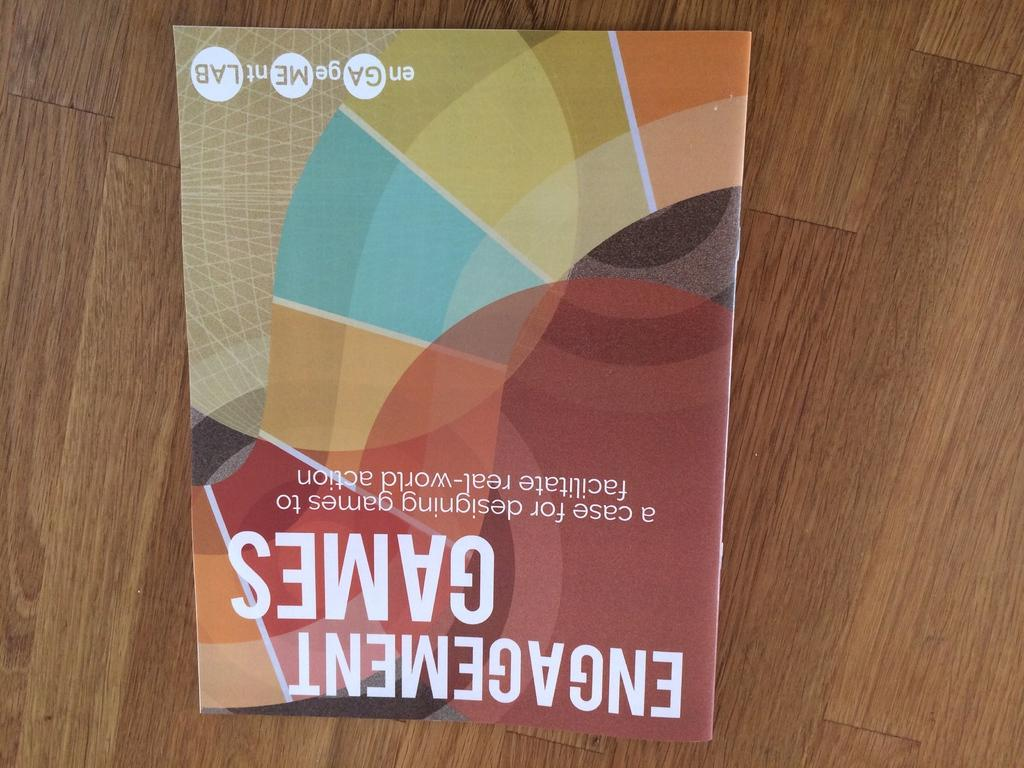What object is placed on the table in the image? There is a magazine on a table in the image. Can you describe the setting where the magazine is located? The image may have been taken in a room, but there is not enough information to confirm this. How many women are shown holding a grape in the image? There are no women or grapes present in the image; it only features a magazine on a table. 